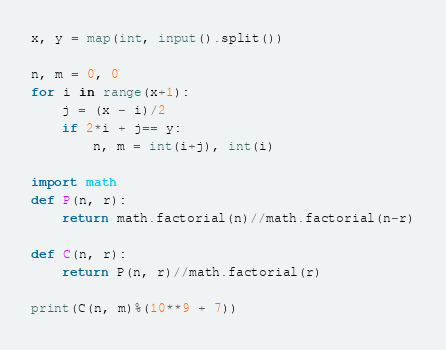<code> <loc_0><loc_0><loc_500><loc_500><_Python_>x, y = map(int, input().split())

n, m = 0, 0
for i in range(x+1):
    j = (x - i)/2
    if 2*i + j== y:
        n, m = int(i+j), int(i)

import math
def P(n, r):
    return math.factorial(n)//math.factorial(n-r)

def C(n, r):
    return P(n, r)//math.factorial(r)

print(C(n, m)%(10**9 + 7))</code> 